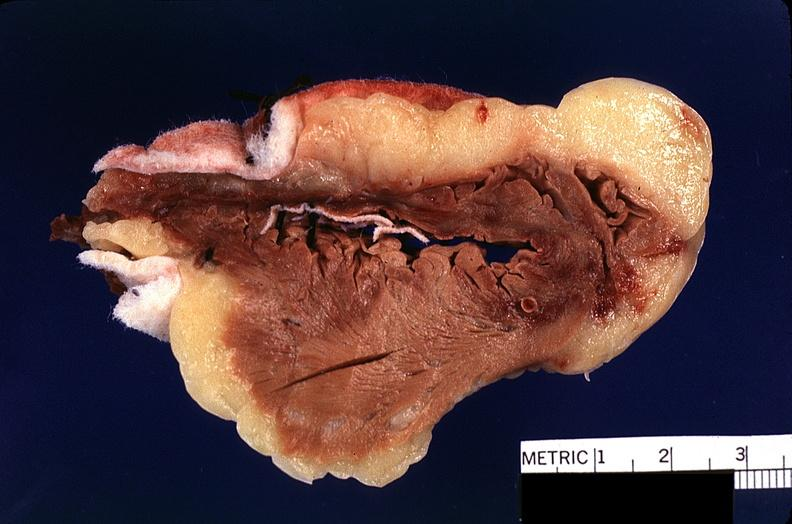s cardiovascular present?
Answer the question using a single word or phrase. Yes 